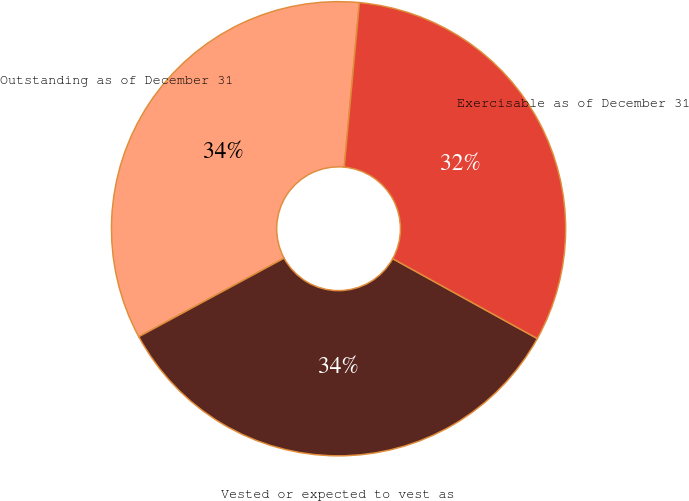Convert chart to OTSL. <chart><loc_0><loc_0><loc_500><loc_500><pie_chart><fcel>Outstanding as of December 31<fcel>Vested or expected to vest as<fcel>Exercisable as of December 31<nl><fcel>34.35%<fcel>34.08%<fcel>31.57%<nl></chart> 